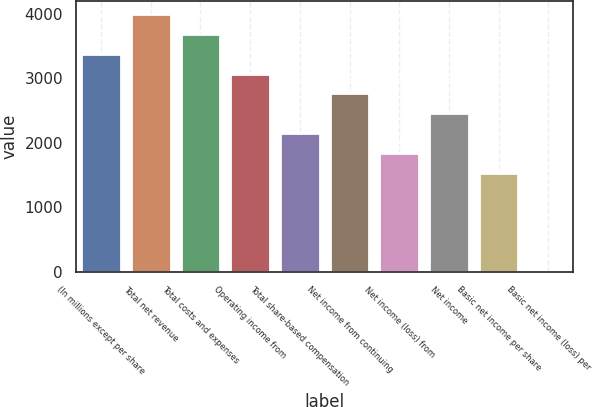Convert chart to OTSL. <chart><loc_0><loc_0><loc_500><loc_500><bar_chart><fcel>(In millions except per share<fcel>Total net revenue<fcel>Total costs and expenses<fcel>Operating income from<fcel>Total share-based compensation<fcel>Net income from continuing<fcel>Net income (loss) from<fcel>Net income<fcel>Basic net income per share<fcel>Basic net income (loss) per<nl><fcel>3380.34<fcel>3994.94<fcel>3687.64<fcel>3073.04<fcel>2151.14<fcel>2765.74<fcel>1843.84<fcel>2458.44<fcel>1536.54<fcel>0.04<nl></chart> 